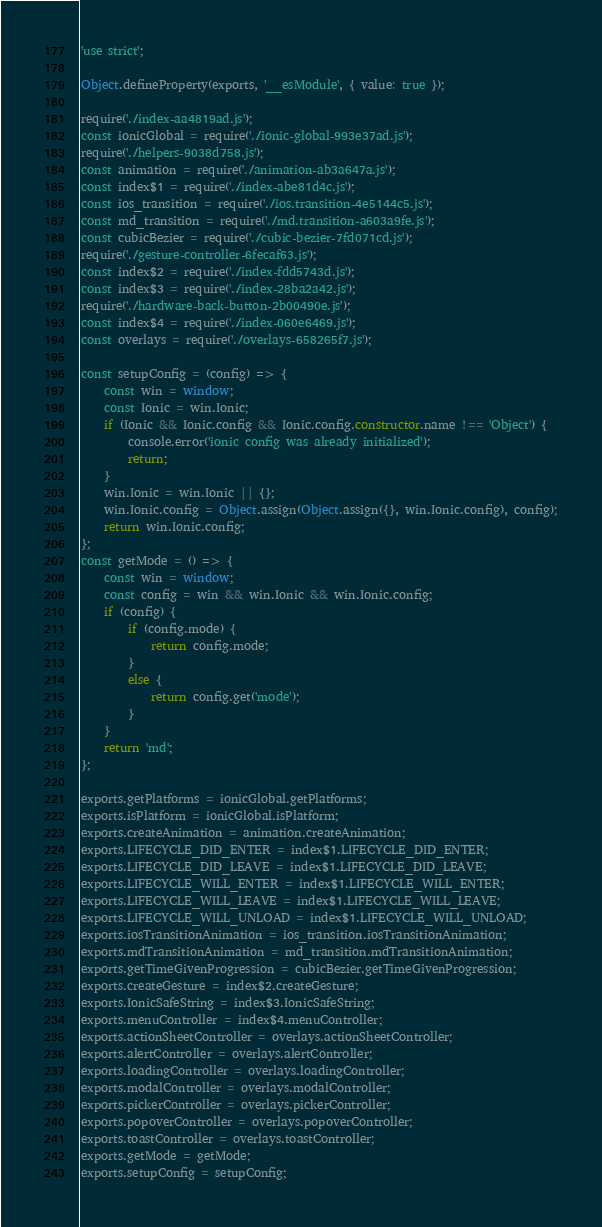Convert code to text. <code><loc_0><loc_0><loc_500><loc_500><_JavaScript_>'use strict';

Object.defineProperty(exports, '__esModule', { value: true });

require('./index-aa4819ad.js');
const ionicGlobal = require('./ionic-global-993e37ad.js');
require('./helpers-9038d758.js');
const animation = require('./animation-ab3a647a.js');
const index$1 = require('./index-abe81d4c.js');
const ios_transition = require('./ios.transition-4e5144c5.js');
const md_transition = require('./md.transition-a603a9fe.js');
const cubicBezier = require('./cubic-bezier-7fd071cd.js');
require('./gesture-controller-6fecaf63.js');
const index$2 = require('./index-fdd5743d.js');
const index$3 = require('./index-28ba2a42.js');
require('./hardware-back-button-2b00490e.js');
const index$4 = require('./index-060e6469.js');
const overlays = require('./overlays-658265f7.js');

const setupConfig = (config) => {
    const win = window;
    const Ionic = win.Ionic;
    if (Ionic && Ionic.config && Ionic.config.constructor.name !== 'Object') {
        console.error('ionic config was already initialized');
        return;
    }
    win.Ionic = win.Ionic || {};
    win.Ionic.config = Object.assign(Object.assign({}, win.Ionic.config), config);
    return win.Ionic.config;
};
const getMode = () => {
    const win = window;
    const config = win && win.Ionic && win.Ionic.config;
    if (config) {
        if (config.mode) {
            return config.mode;
        }
        else {
            return config.get('mode');
        }
    }
    return 'md';
};

exports.getPlatforms = ionicGlobal.getPlatforms;
exports.isPlatform = ionicGlobal.isPlatform;
exports.createAnimation = animation.createAnimation;
exports.LIFECYCLE_DID_ENTER = index$1.LIFECYCLE_DID_ENTER;
exports.LIFECYCLE_DID_LEAVE = index$1.LIFECYCLE_DID_LEAVE;
exports.LIFECYCLE_WILL_ENTER = index$1.LIFECYCLE_WILL_ENTER;
exports.LIFECYCLE_WILL_LEAVE = index$1.LIFECYCLE_WILL_LEAVE;
exports.LIFECYCLE_WILL_UNLOAD = index$1.LIFECYCLE_WILL_UNLOAD;
exports.iosTransitionAnimation = ios_transition.iosTransitionAnimation;
exports.mdTransitionAnimation = md_transition.mdTransitionAnimation;
exports.getTimeGivenProgression = cubicBezier.getTimeGivenProgression;
exports.createGesture = index$2.createGesture;
exports.IonicSafeString = index$3.IonicSafeString;
exports.menuController = index$4.menuController;
exports.actionSheetController = overlays.actionSheetController;
exports.alertController = overlays.alertController;
exports.loadingController = overlays.loadingController;
exports.modalController = overlays.modalController;
exports.pickerController = overlays.pickerController;
exports.popoverController = overlays.popoverController;
exports.toastController = overlays.toastController;
exports.getMode = getMode;
exports.setupConfig = setupConfig;
</code> 